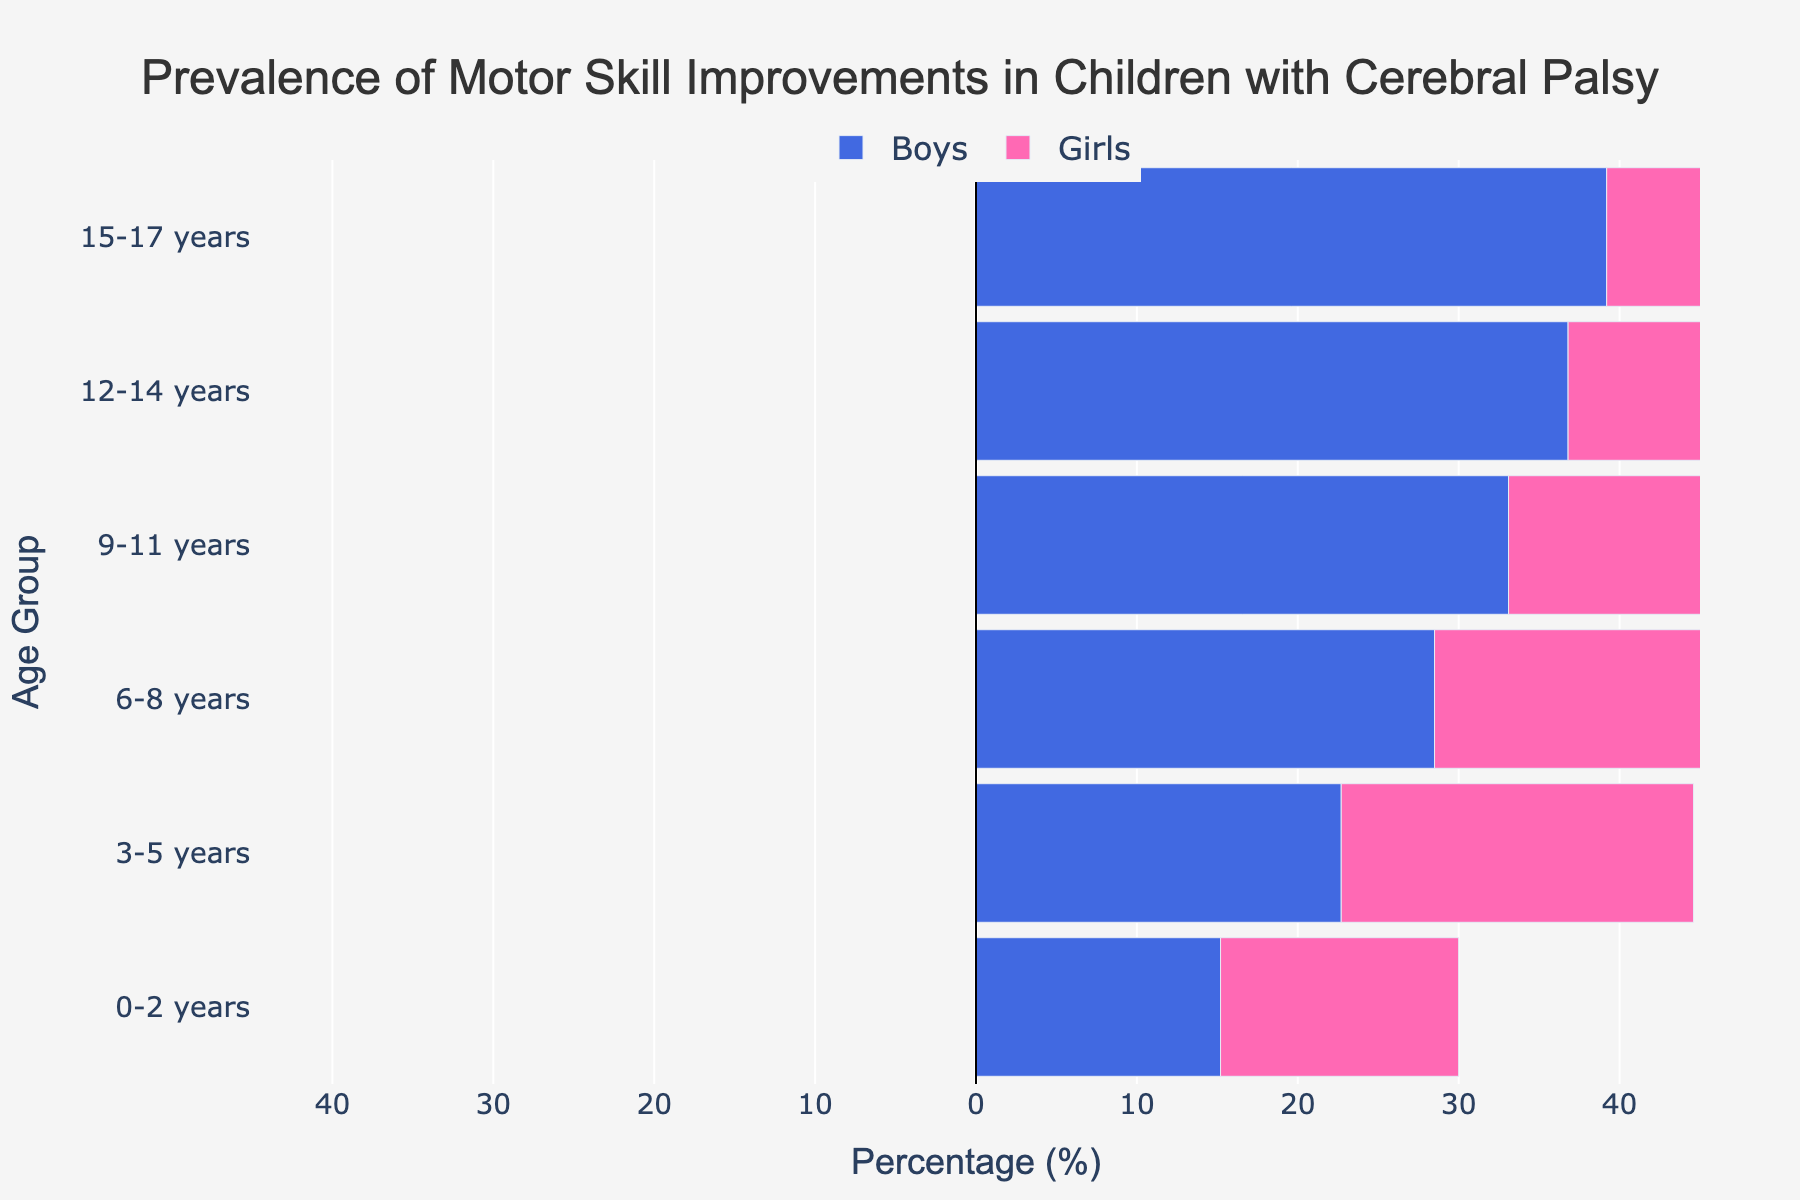What is the title of the figure? The title of the figure is located at the top center and provides the main subject of the figure. The title reads "Prevalence of Motor Skill Improvements in Children with Cerebral Palsy."
Answer: Prevalence of Motor Skill Improvements in Children with Cerebral Palsy What are the color representations for boys and girls on the figure? The colors used in the figure represent boys and girls. The color for boys is blue, and the color for girls is pink.
Answer: Blue for boys, Pink for girls Which age group has the highest prevalence of motor skill improvements in girls? To find the highest prevalence in girls, identify the age group with the largest positive bar on the right side of the pyramid. The 15-17 years age group has the highest prevalence at 38.5%.
Answer: 15-17 years What is the prevalence of motor skill improvements in boys aged 12-14 years? To find this value, look at the negative bar corresponding to the 12-14 years age group on the left side of the pyramid. It is -36.8%.
Answer: 36.8% How does the prevalence of motor skill improvements for boys compare to girls in the 9-11 years age group? Compare the lengths of the bars for boys and girls in the 9-11 years age group. Boys have a prevalence of -33.1% and girls 32.4%, so boys have a slightly higher prevalence.
Answer: Boys have a higher prevalence What is the percentage difference in motor skill improvements between boys and girls in the 3-5 years age group? To find the percentage difference, subtract the prevalence percentage of girls from boys: 22.7 - 21.9 = 0.8%.
Answer: 0.8% Which age group shows the least difference in prevalence between boys and girls? Compare the difference for all age groups. The age group with the smallest absolute difference in percentage values is 3-5 years with a difference of 0.8%.
Answer: 3-5 years Are there more boys or girls showing motor skill improvements in younger age groups (0-8 years)? Sum the percentages for boys and girls in the 0-2, 3-5, and 6-8 years groups: Boys: 15.2 + 22.7 + 28.5 = 66.4%, Girls: 14.8 + 21.9 + 27.6 = 64.3%. Boys have higher prevalence.
Answer: Boys How does the overall trend of motor skill improvements compare between boys and girls as age increases? For both boys and girls, the prevalence of motor skill improvements increases with age. Boys start lower but end with a higher prevalence rate. Girls start slightly lower as well but remain behind boys in percentages.
Answer: Increases for both boys and girls but boys have higher rates What is the range of prevalence percentages shown for boys and girls combined? The range can be determined by looking at the maximum and minimum prevalence percentages. For boys, the range is from 15.2% to 39.2%, and for girls, it's from 14.8% to 38.5%.
Answer: 14.8% to 39.2% 